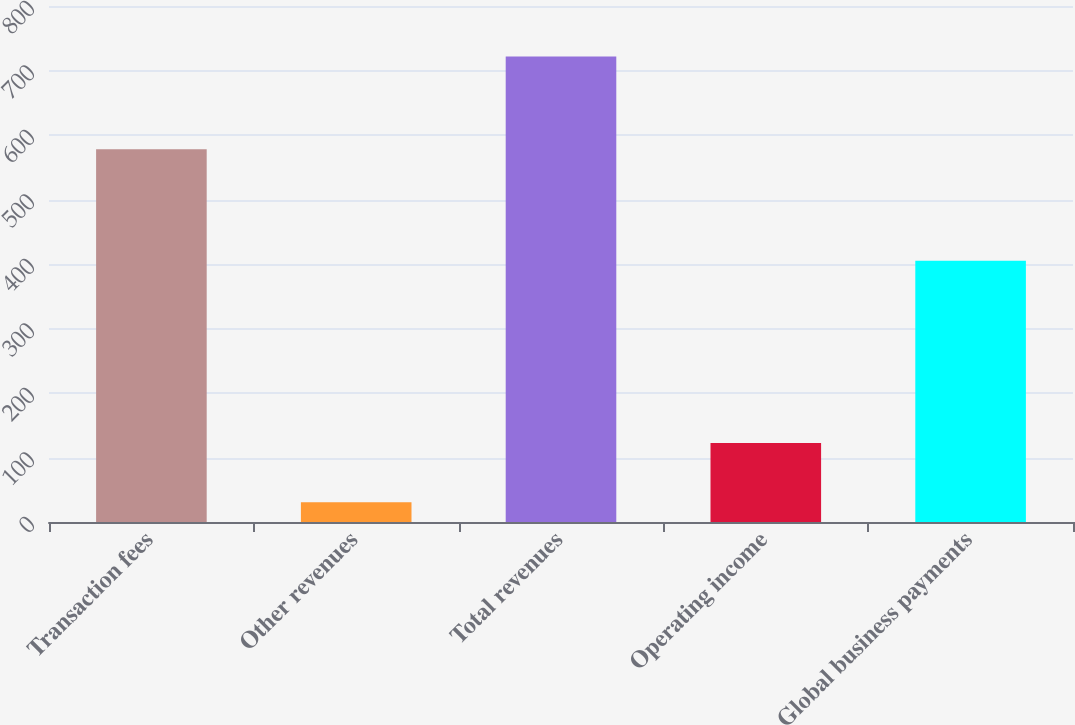<chart> <loc_0><loc_0><loc_500><loc_500><bar_chart><fcel>Transaction fees<fcel>Other revenues<fcel>Total revenues<fcel>Operating income<fcel>Global business payments<nl><fcel>578<fcel>30.7<fcel>721.7<fcel>122.5<fcel>404.9<nl></chart> 